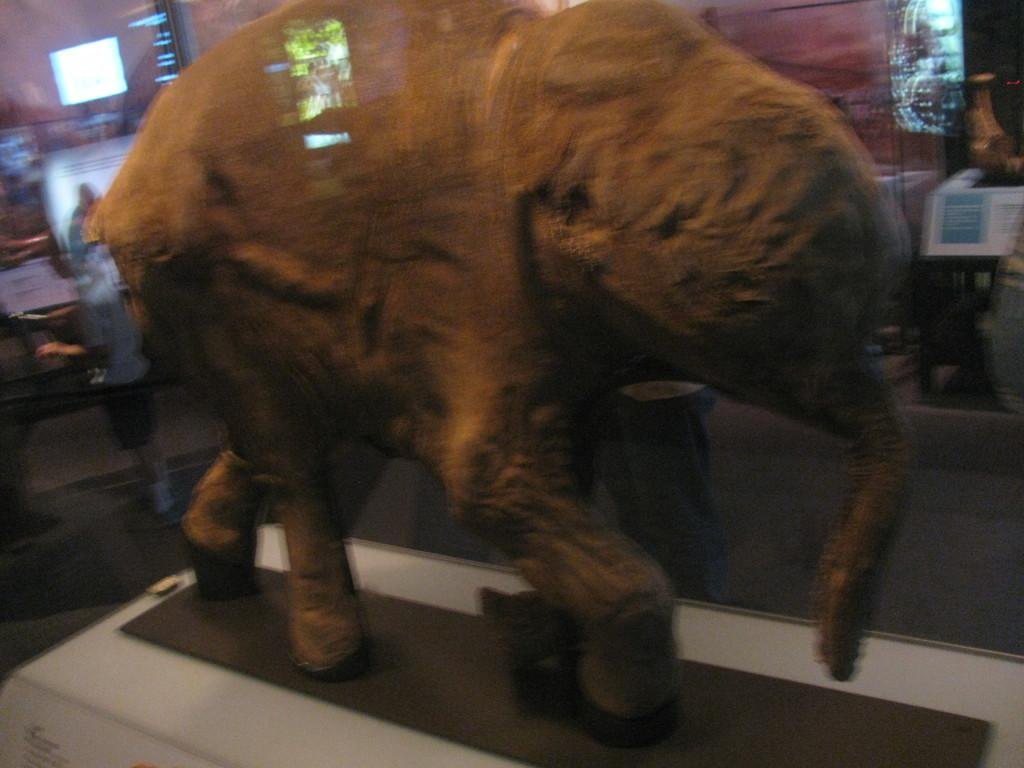What is the main subject of the image? The main subject of the image is an elephant statue on a platform. What can be seen in the background of the image? There is a screen and other objects visible in the background of the image. Are there any people present in the image? Yes, two persons are present in the background of the image. What type of plough is being used by the toad in the image? There is no toad or plough present in the image. How many forks can be seen in the image? There are no forks visible in the image. 